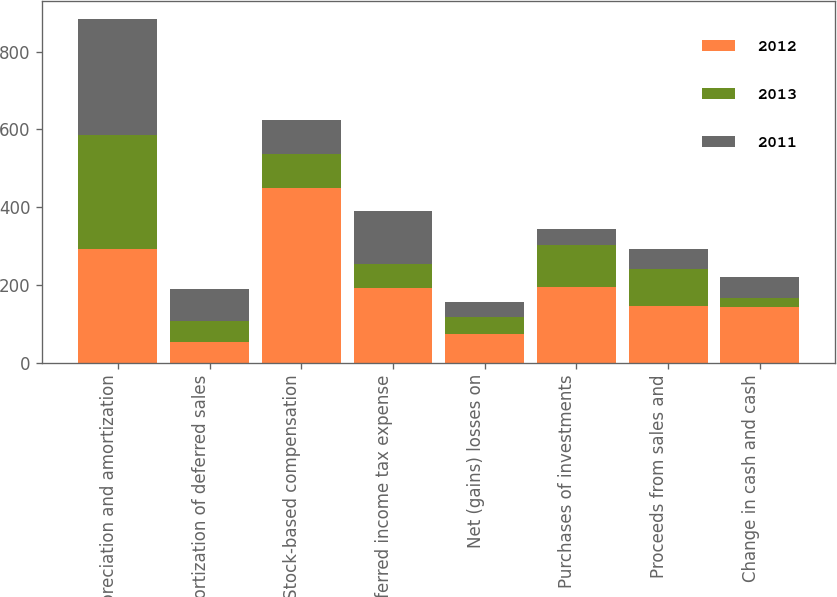Convert chart to OTSL. <chart><loc_0><loc_0><loc_500><loc_500><stacked_bar_chart><ecel><fcel>Depreciation and amortization<fcel>Amortization of deferred sales<fcel>Stock-based compensation<fcel>Deferred income tax expense<fcel>Net (gains) losses on<fcel>Purchases of investments<fcel>Proceeds from sales and<fcel>Change in cash and cash<nl><fcel>2012<fcel>291<fcel>52<fcel>448<fcel>193<fcel>73<fcel>195<fcel>145<fcel>143<nl><fcel>2013<fcel>295<fcel>55<fcel>88.5<fcel>61<fcel>43<fcel>108<fcel>96<fcel>24<nl><fcel>2011<fcel>299<fcel>81<fcel>88.5<fcel>137<fcel>40<fcel>41<fcel>50<fcel>54<nl></chart> 